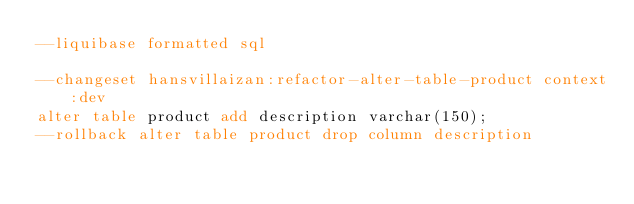<code> <loc_0><loc_0><loc_500><loc_500><_SQL_>--liquibase formatted sql

--changeset hansvillaizan:refactor-alter-table-product context:dev
alter table product add description varchar(150);
--rollback alter table product drop column description</code> 